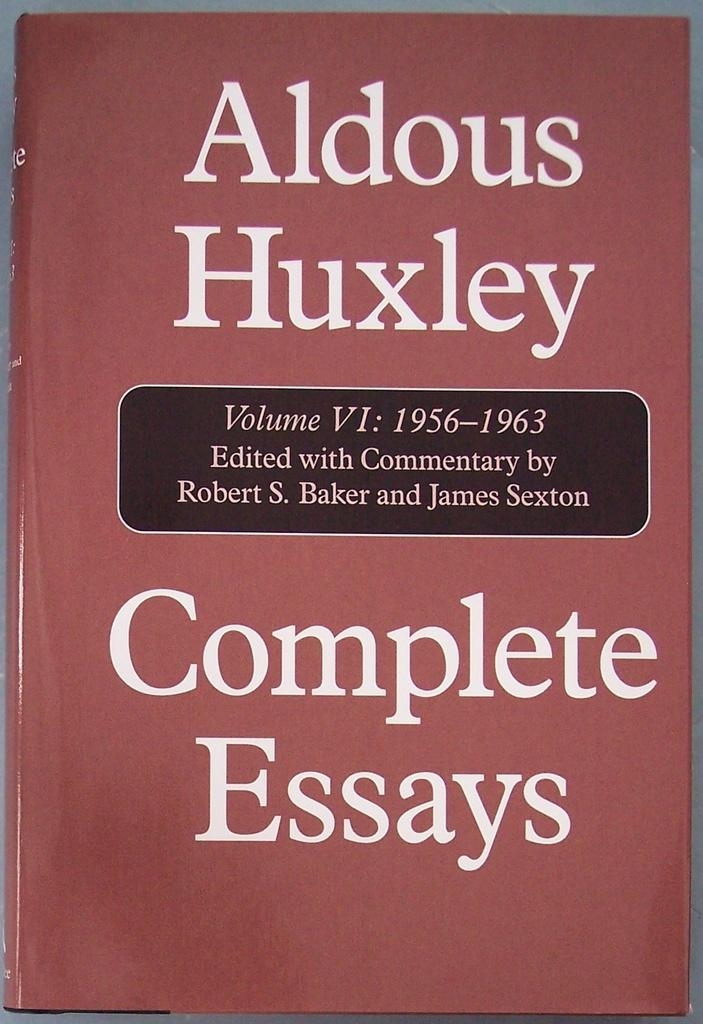<image>
Provide a brief description of the given image. The book shown is compiled of complete essays. 